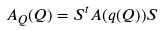<formula> <loc_0><loc_0><loc_500><loc_500>A _ { Q } ( Q ) = S ^ { t } A ( q ( Q ) ) S</formula> 